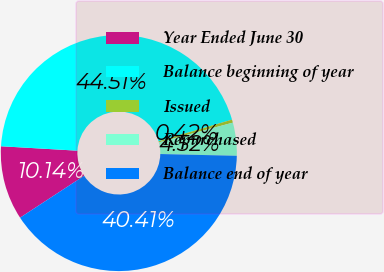Convert chart. <chart><loc_0><loc_0><loc_500><loc_500><pie_chart><fcel>Year Ended June 30<fcel>Balance beginning of year<fcel>Issued<fcel>Repurchased<fcel>Balance end of year<nl><fcel>10.14%<fcel>44.51%<fcel>0.42%<fcel>4.52%<fcel>40.41%<nl></chart> 